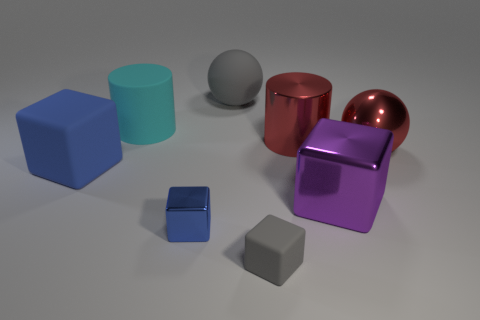Subtract 1 cubes. How many cubes are left? 3 Add 1 big purple blocks. How many objects exist? 9 Subtract all spheres. How many objects are left? 6 Add 4 purple objects. How many purple objects are left? 5 Add 7 large red things. How many large red things exist? 9 Subtract 1 gray spheres. How many objects are left? 7 Subtract all blocks. Subtract all red shiny objects. How many objects are left? 2 